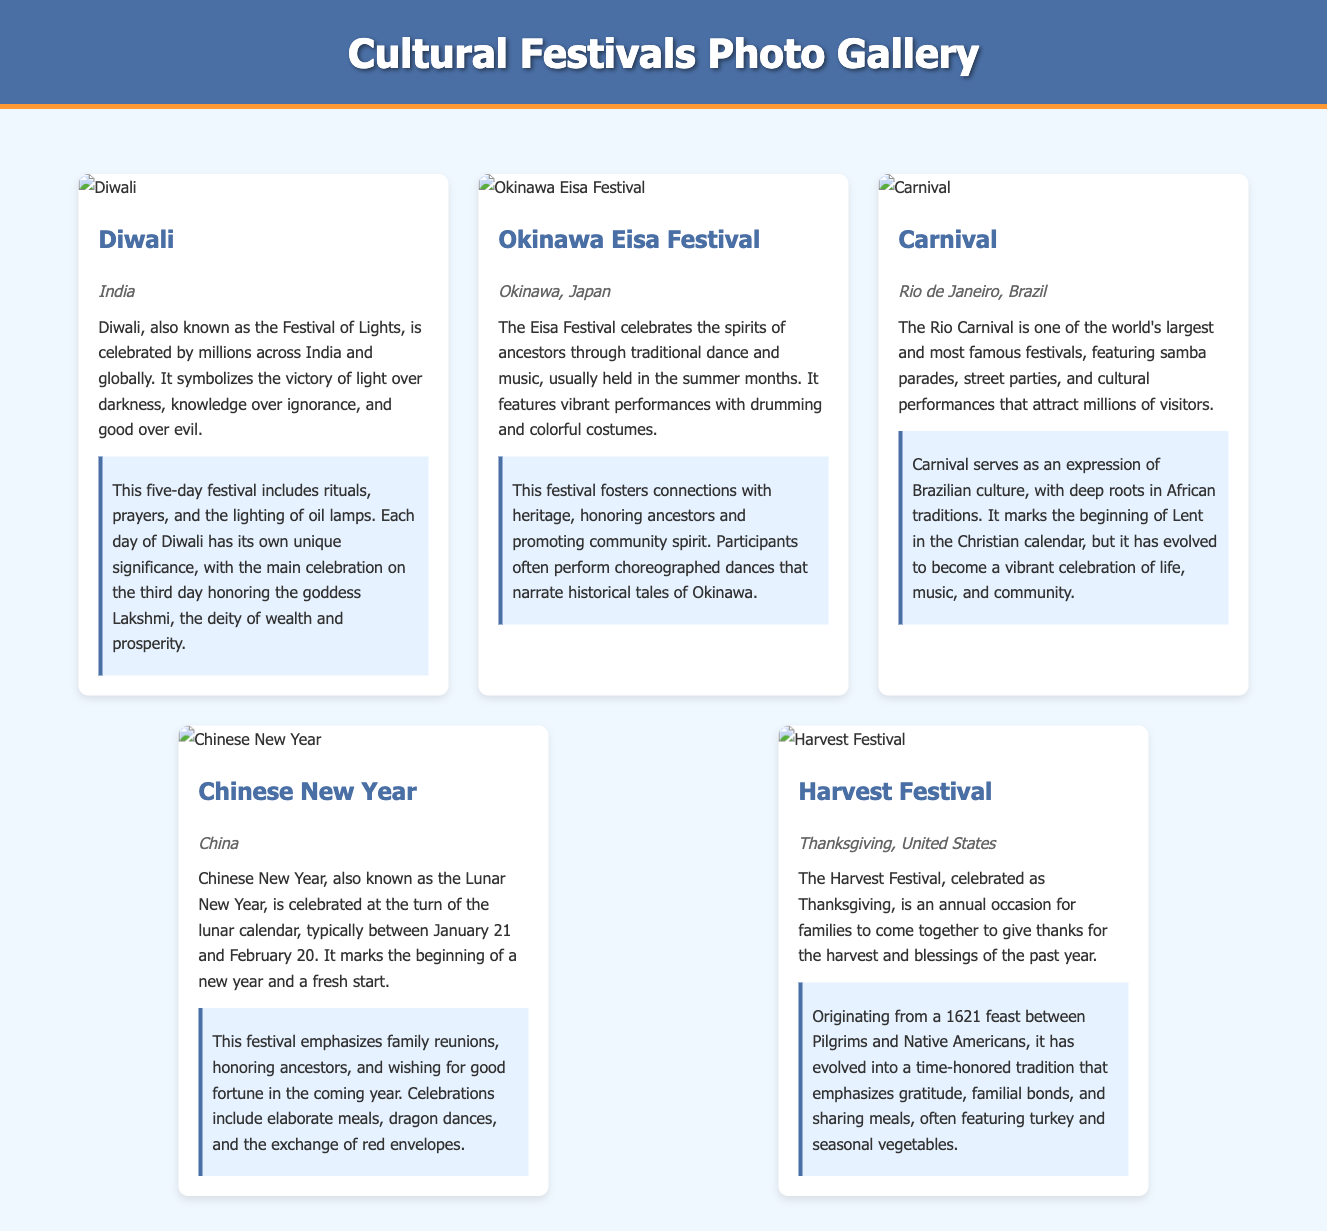What is the significance of Diwali? The description mentions that Diwali symbolizes the victory of light over darkness, knowledge over ignorance, and good over evil, with various rituals and prayers.
Answer: Victory of light over darkness Where is the Okinawa Eisa Festival celebrated? The document states that the Okinawa Eisa Festival is located in Okinawa, Japan.
Answer: Okinawa, Japan What type of performances are featured at the Rio Carnival? The document describes the Rio Carnival featuring samba parades, street parties, and cultural performances.
Answer: Samba parades How many days does Diwali last? The explanation states that Diwali is a five-day festival.
Answer: Five days What is exchanged during Chinese New Year celebrations? The document mentions that the exchange of red envelopes is a part of the celebrations.
Answer: Red envelopes What is the origin year of the Harvest Festival as mentioned? The document notes that the Harvest Festival's origins trace back to a feast in 1621.
Answer: 1621 Which goddess is honored on the third day of Diwali? The description states that the goddess Lakshmi is honored on the third day.
Answer: Lakshmi What is the central theme of the Harvest Festival? The explanation indicates that the central theme is giving thanks for the harvest and blessings of the past year.
Answer: Giving thanks 